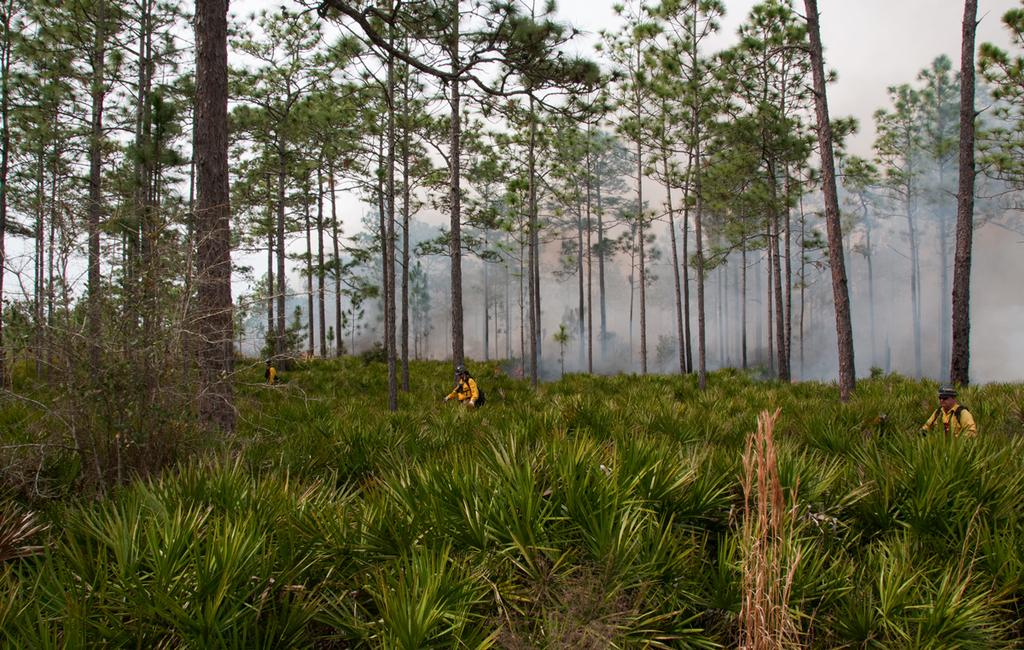What can be seen in the sky in the image? The sky is visible in the image. What type of natural elements are present in the image? There are trees and plants in the image. What might be causing the smoke in the image? The source of the smoke is not specified in the image. How many people are in the image? There are people in the image. What type of wool is being used by the company in the image? There is no mention of wool or a company in the image. What knowledge can be gained from the image? The image provides visual information about the sky, trees, plants, smoke, and people, but it does not convey any specific knowledge or teach any lessons. 